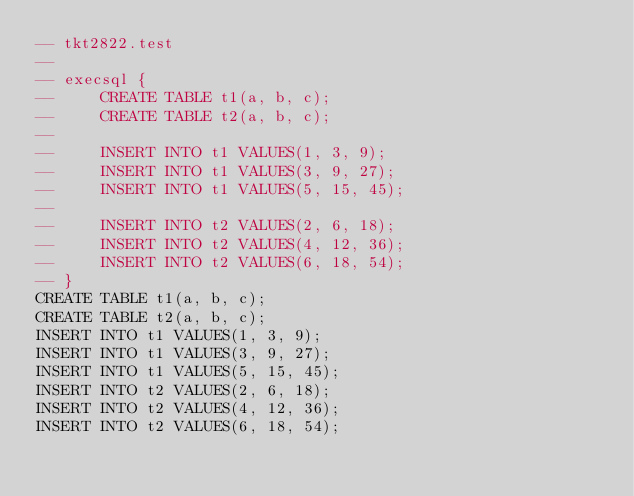Convert code to text. <code><loc_0><loc_0><loc_500><loc_500><_SQL_>-- tkt2822.test
-- 
-- execsql {
--     CREATE TABLE t1(a, b, c);
--     CREATE TABLE t2(a, b, c);
-- 
--     INSERT INTO t1 VALUES(1, 3, 9);
--     INSERT INTO t1 VALUES(3, 9, 27);
--     INSERT INTO t1 VALUES(5, 15, 45);
-- 
--     INSERT INTO t2 VALUES(2, 6, 18);
--     INSERT INTO t2 VALUES(4, 12, 36);
--     INSERT INTO t2 VALUES(6, 18, 54);
-- }
CREATE TABLE t1(a, b, c);
CREATE TABLE t2(a, b, c);
INSERT INTO t1 VALUES(1, 3, 9);
INSERT INTO t1 VALUES(3, 9, 27);
INSERT INTO t1 VALUES(5, 15, 45);
INSERT INTO t2 VALUES(2, 6, 18);
INSERT INTO t2 VALUES(4, 12, 36);
INSERT INTO t2 VALUES(6, 18, 54);</code> 